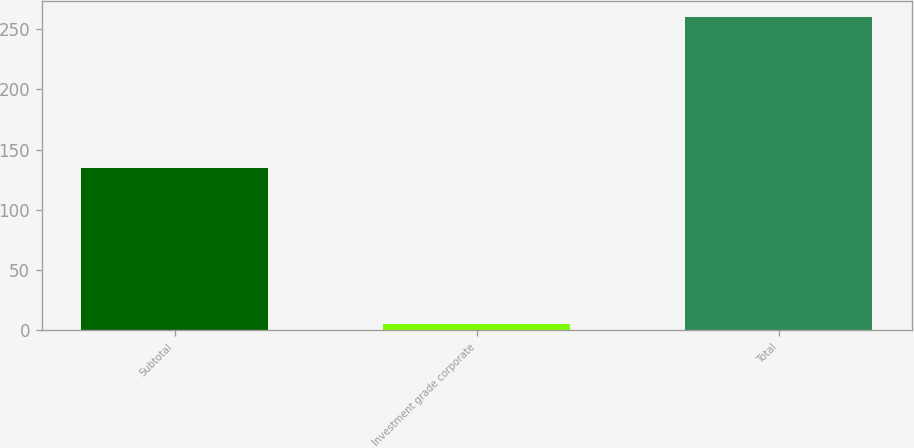Convert chart to OTSL. <chart><loc_0><loc_0><loc_500><loc_500><bar_chart><fcel>Subtotal<fcel>Investment grade corporate<fcel>Total<nl><fcel>135<fcel>5<fcel>260<nl></chart> 